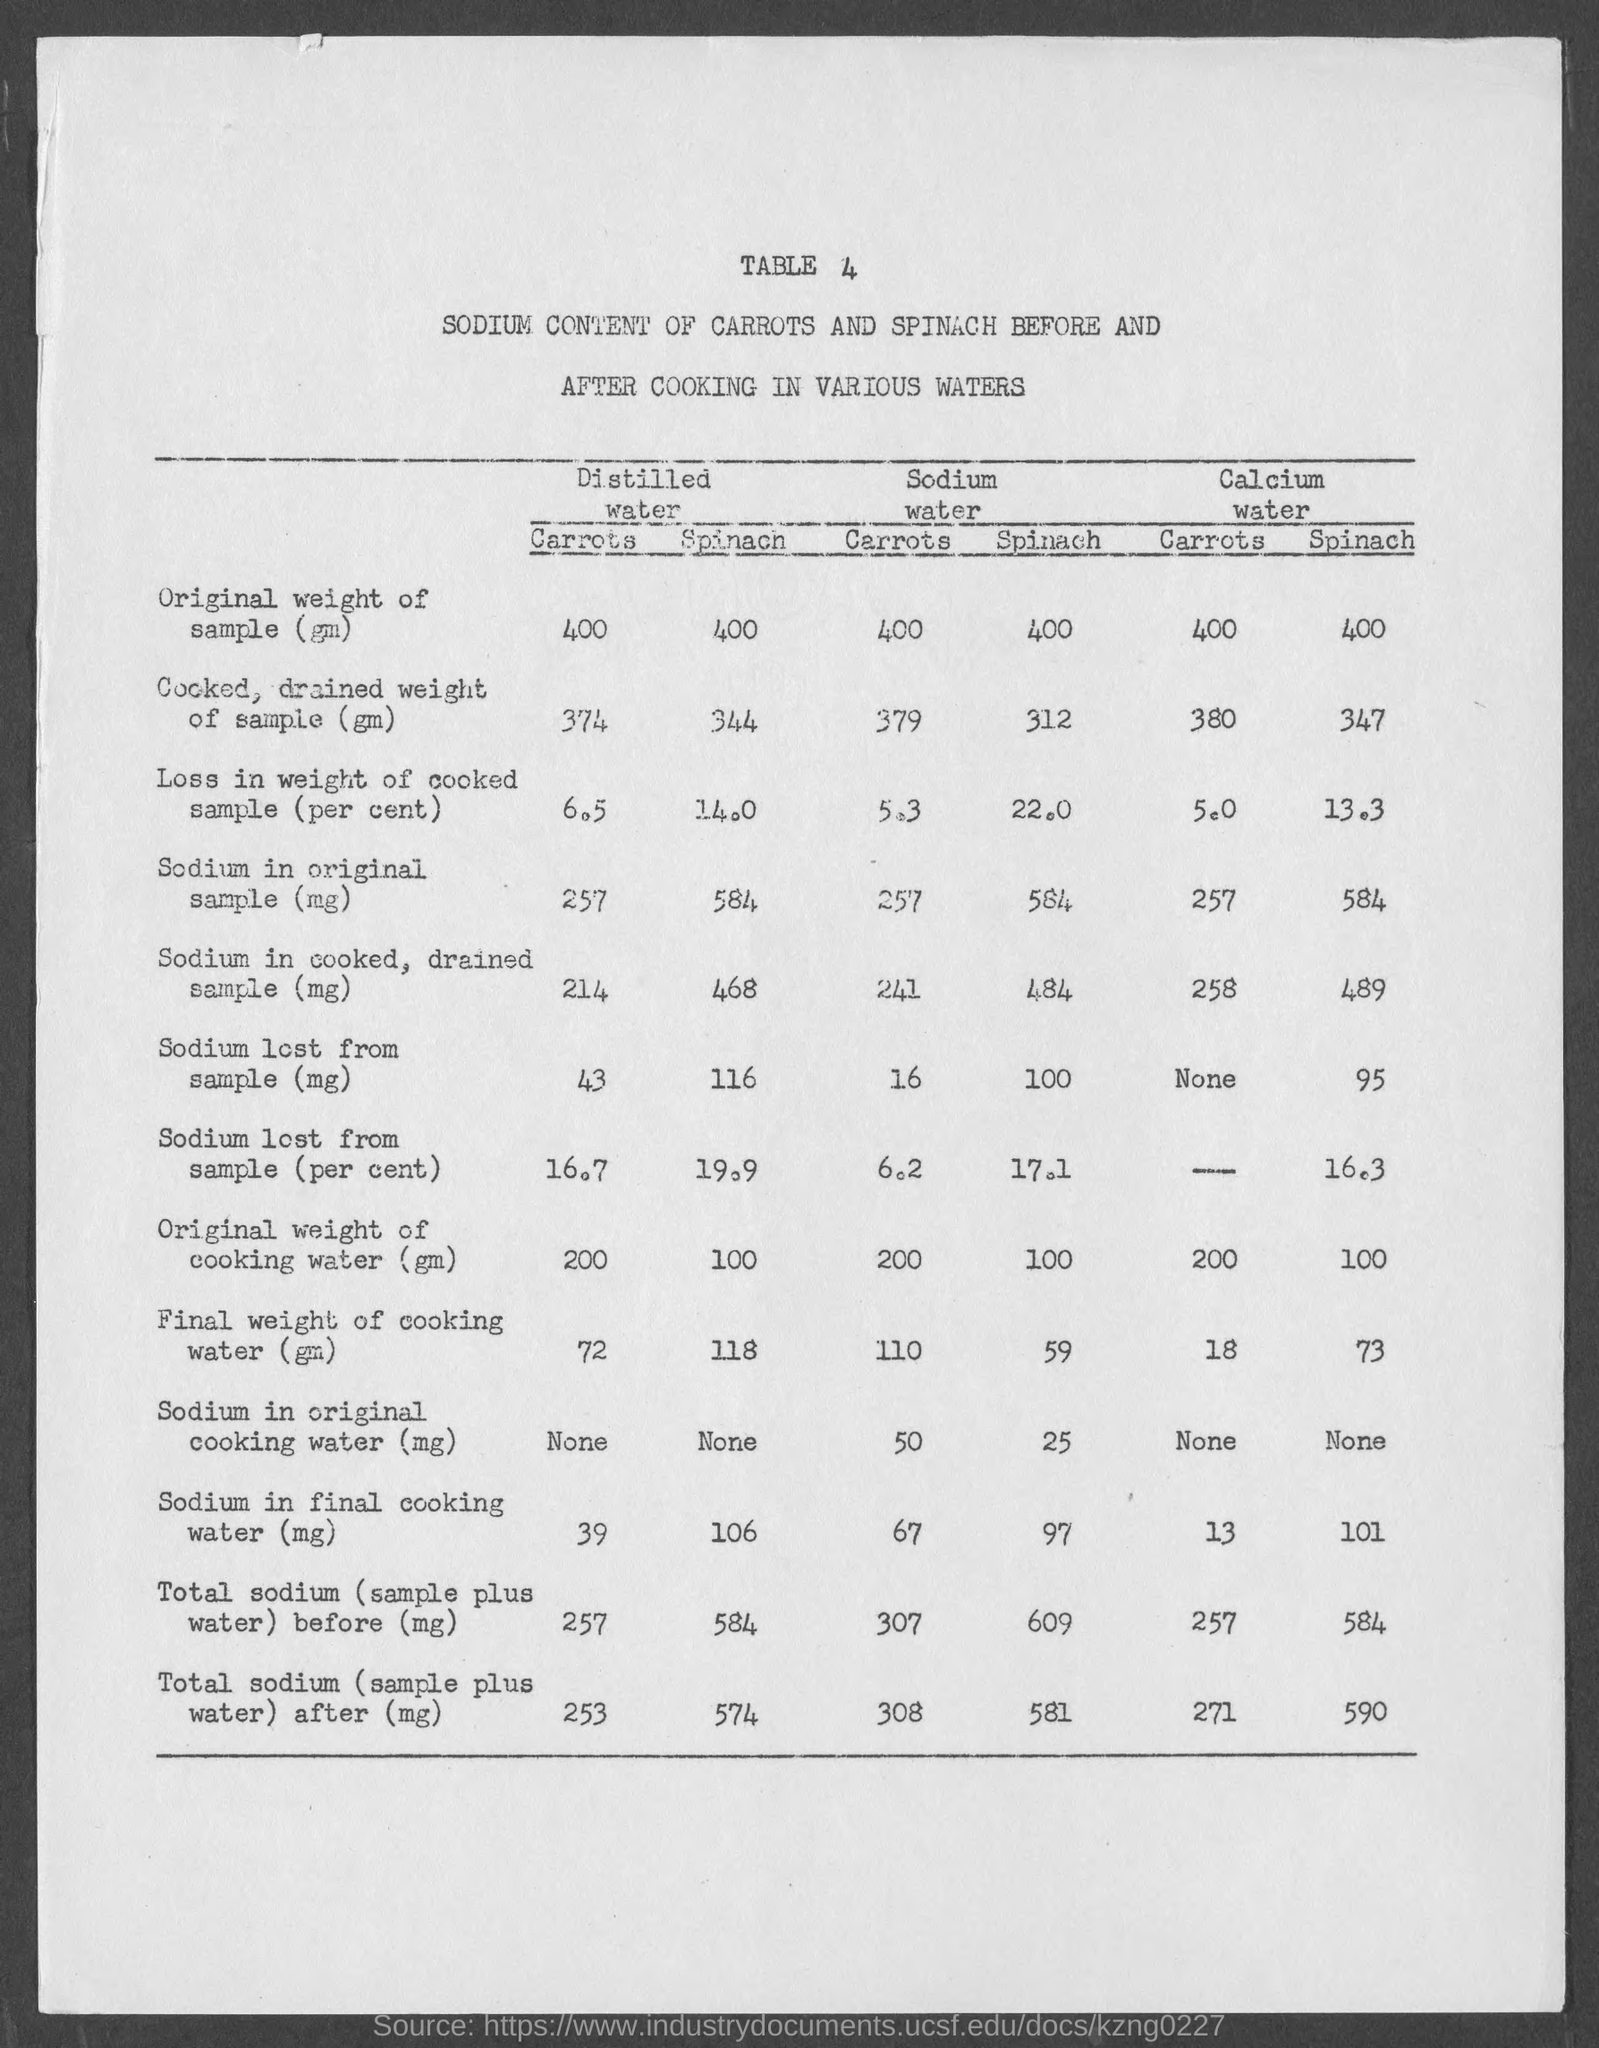Identify some key points in this picture. What is the table number?" is a question that needs to be answered. 